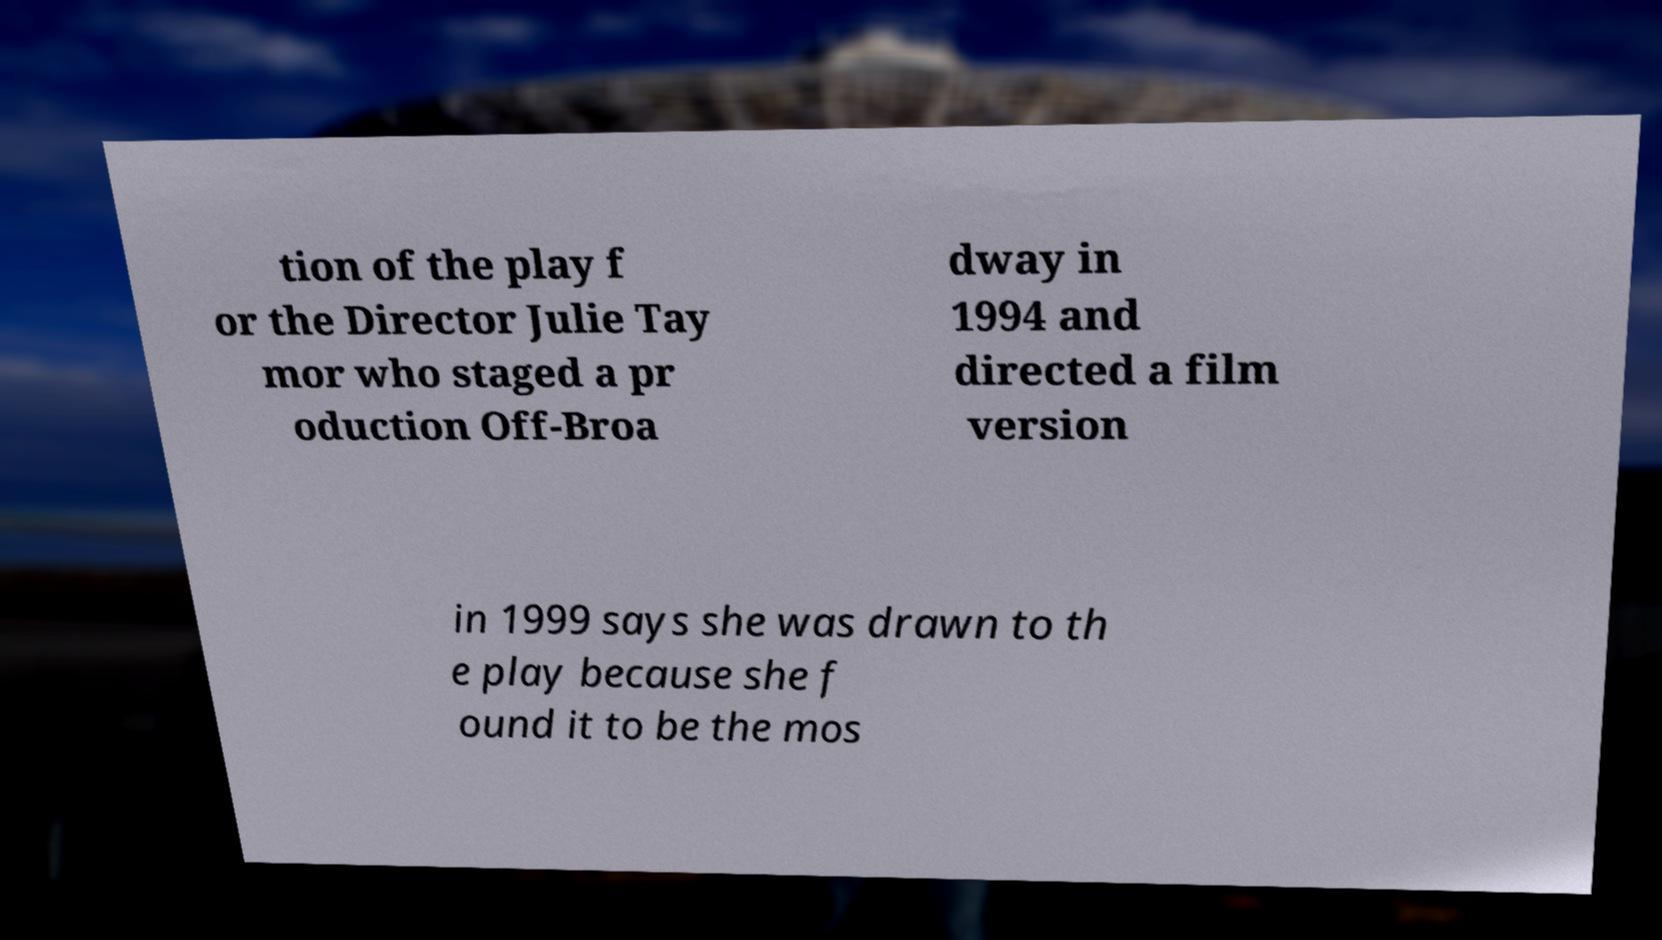Could you extract and type out the text from this image? tion of the play f or the Director Julie Tay mor who staged a pr oduction Off-Broa dway in 1994 and directed a film version in 1999 says she was drawn to th e play because she f ound it to be the mos 